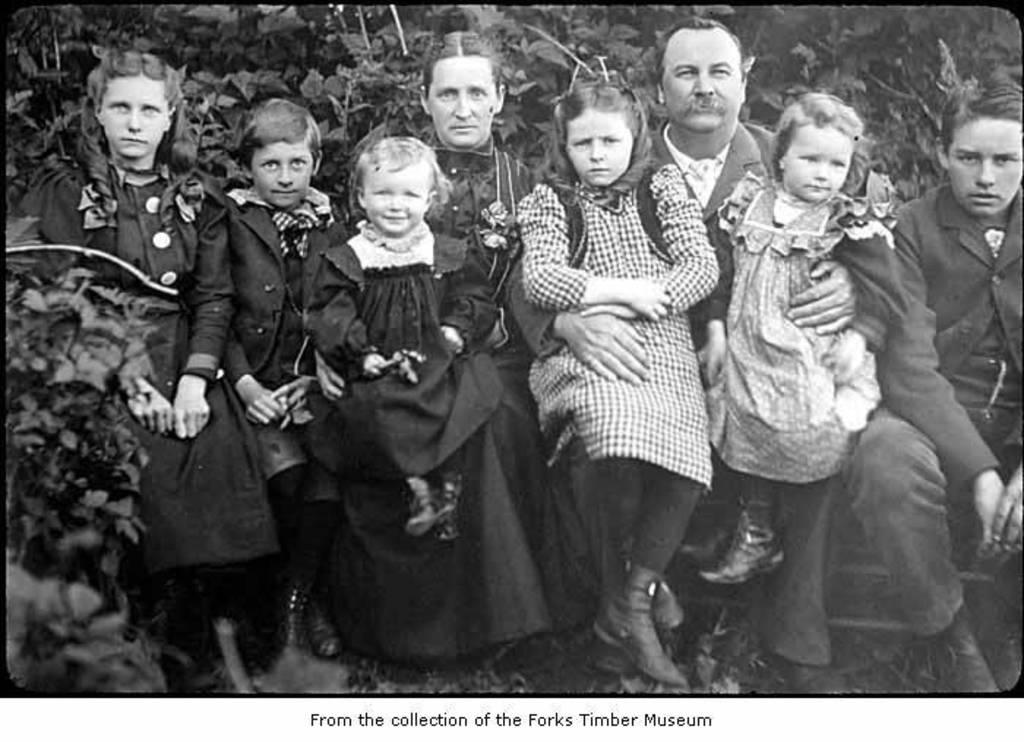Who or what can be seen in the image? There are people in the image. What type of natural elements are present in the image? There are trees and plants in the image. What type of eggs can be seen on the seashore in the image? There is no seashore or eggs present in the image; it features people and natural elements like trees and plants. 